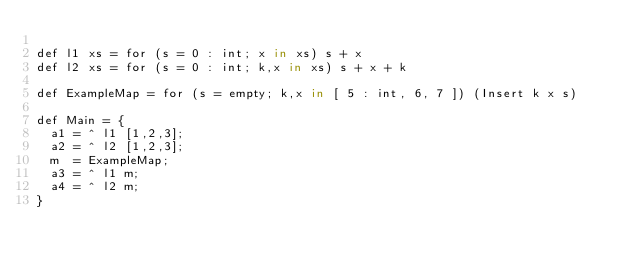<code> <loc_0><loc_0><loc_500><loc_500><_SQL_>
def l1 xs = for (s = 0 : int; x in xs) s + x
def l2 xs = for (s = 0 : int; k,x in xs) s + x + k

def ExampleMap = for (s = empty; k,x in [ 5 : int, 6, 7 ]) (Insert k x s)

def Main = {
  a1 = ^ l1 [1,2,3];
  a2 = ^ l2 [1,2,3];
  m  = ExampleMap;
  a3 = ^ l1 m;
  a4 = ^ l2 m;
}



</code> 